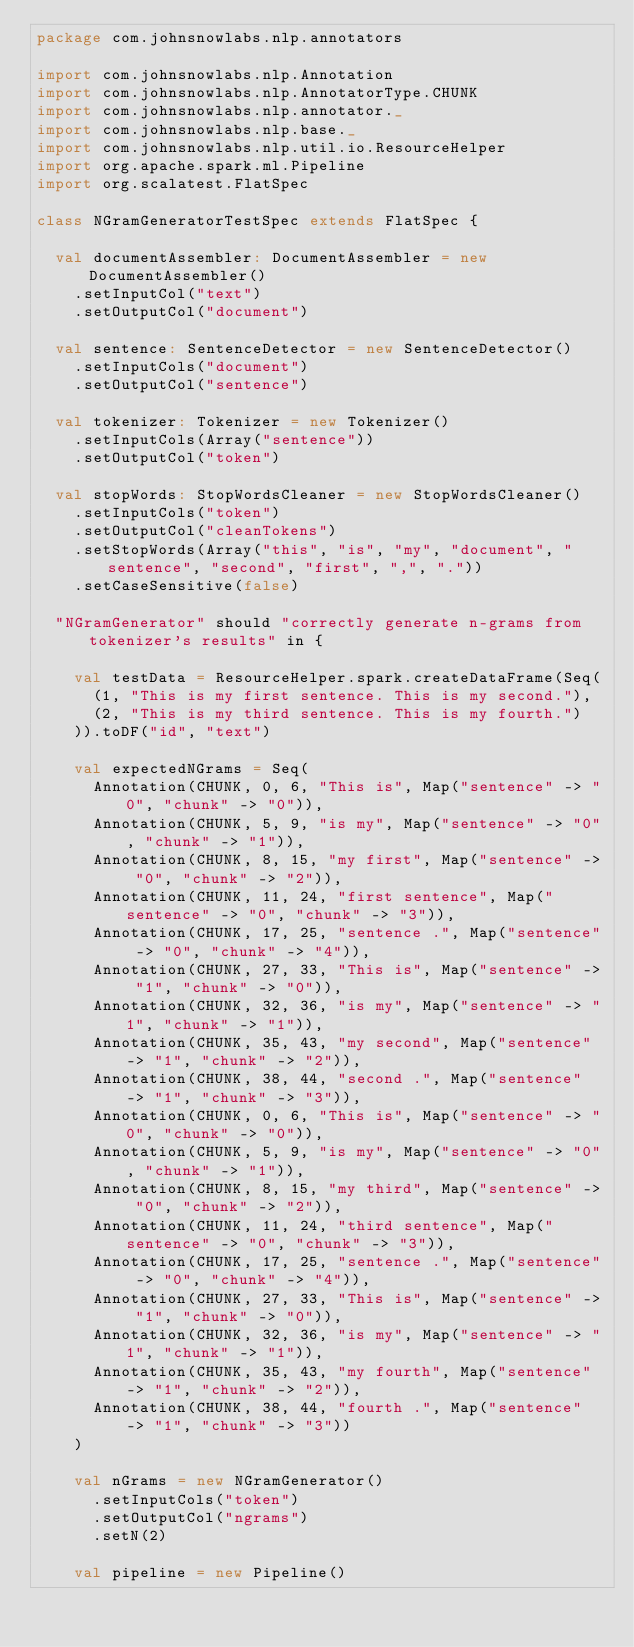Convert code to text. <code><loc_0><loc_0><loc_500><loc_500><_Scala_>package com.johnsnowlabs.nlp.annotators

import com.johnsnowlabs.nlp.Annotation
import com.johnsnowlabs.nlp.AnnotatorType.CHUNK
import com.johnsnowlabs.nlp.annotator._
import com.johnsnowlabs.nlp.base._
import com.johnsnowlabs.nlp.util.io.ResourceHelper
import org.apache.spark.ml.Pipeline
import org.scalatest.FlatSpec

class NGramGeneratorTestSpec extends FlatSpec {

  val documentAssembler: DocumentAssembler = new DocumentAssembler()
    .setInputCol("text")
    .setOutputCol("document")

  val sentence: SentenceDetector = new SentenceDetector()
    .setInputCols("document")
    .setOutputCol("sentence")

  val tokenizer: Tokenizer = new Tokenizer()
    .setInputCols(Array("sentence"))
    .setOutputCol("token")

  val stopWords: StopWordsCleaner = new StopWordsCleaner()
    .setInputCols("token")
    .setOutputCol("cleanTokens")
    .setStopWords(Array("this", "is", "my", "document", "sentence", "second", "first", ",", "."))
    .setCaseSensitive(false)

  "NGramGenerator" should "correctly generate n-grams from tokenizer's results" in {

    val testData = ResourceHelper.spark.createDataFrame(Seq(
      (1, "This is my first sentence. This is my second."),
      (2, "This is my third sentence. This is my fourth.")
    )).toDF("id", "text")

    val expectedNGrams = Seq(
      Annotation(CHUNK, 0, 6, "This is", Map("sentence" -> "0", "chunk" -> "0")),
      Annotation(CHUNK, 5, 9, "is my", Map("sentence" -> "0", "chunk" -> "1")),
      Annotation(CHUNK, 8, 15, "my first", Map("sentence" -> "0", "chunk" -> "2")),
      Annotation(CHUNK, 11, 24, "first sentence", Map("sentence" -> "0", "chunk" -> "3")),
      Annotation(CHUNK, 17, 25, "sentence .", Map("sentence" -> "0", "chunk" -> "4")),
      Annotation(CHUNK, 27, 33, "This is", Map("sentence" -> "1", "chunk" -> "0")),
      Annotation(CHUNK, 32, 36, "is my", Map("sentence" -> "1", "chunk" -> "1")),
      Annotation(CHUNK, 35, 43, "my second", Map("sentence" -> "1", "chunk" -> "2")),
      Annotation(CHUNK, 38, 44, "second .", Map("sentence" -> "1", "chunk" -> "3")),
      Annotation(CHUNK, 0, 6, "This is", Map("sentence" -> "0", "chunk" -> "0")),
      Annotation(CHUNK, 5, 9, "is my", Map("sentence" -> "0", "chunk" -> "1")),
      Annotation(CHUNK, 8, 15, "my third", Map("sentence" -> "0", "chunk" -> "2")),
      Annotation(CHUNK, 11, 24, "third sentence", Map("sentence" -> "0", "chunk" -> "3")),
      Annotation(CHUNK, 17, 25, "sentence .", Map("sentence" -> "0", "chunk" -> "4")),
      Annotation(CHUNK, 27, 33, "This is", Map("sentence" -> "1", "chunk" -> "0")),
      Annotation(CHUNK, 32, 36, "is my", Map("sentence" -> "1", "chunk" -> "1")),
      Annotation(CHUNK, 35, 43, "my fourth", Map("sentence" -> "1", "chunk" -> "2")),
      Annotation(CHUNK, 38, 44, "fourth .", Map("sentence" -> "1", "chunk" -> "3"))
    )

    val nGrams = new NGramGenerator()
      .setInputCols("token")
      .setOutputCol("ngrams")
      .setN(2)

    val pipeline = new Pipeline()</code> 